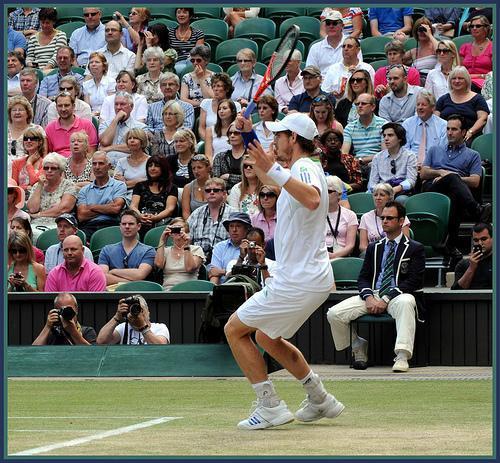How many rackets is the tennis player holding?
Give a very brief answer. 1. 